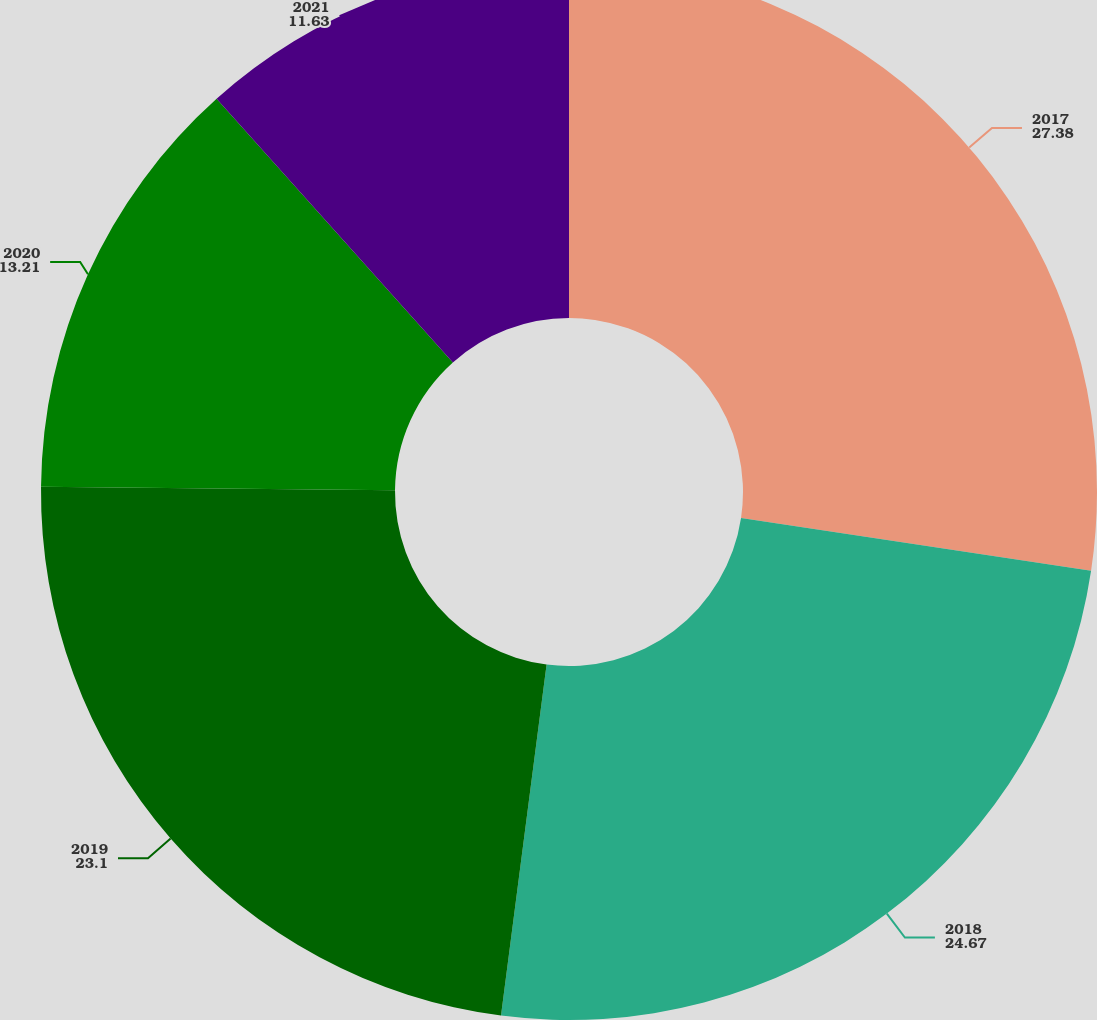<chart> <loc_0><loc_0><loc_500><loc_500><pie_chart><fcel>2017<fcel>2018<fcel>2019<fcel>2020<fcel>2021<nl><fcel>27.38%<fcel>24.67%<fcel>23.1%<fcel>13.21%<fcel>11.63%<nl></chart> 